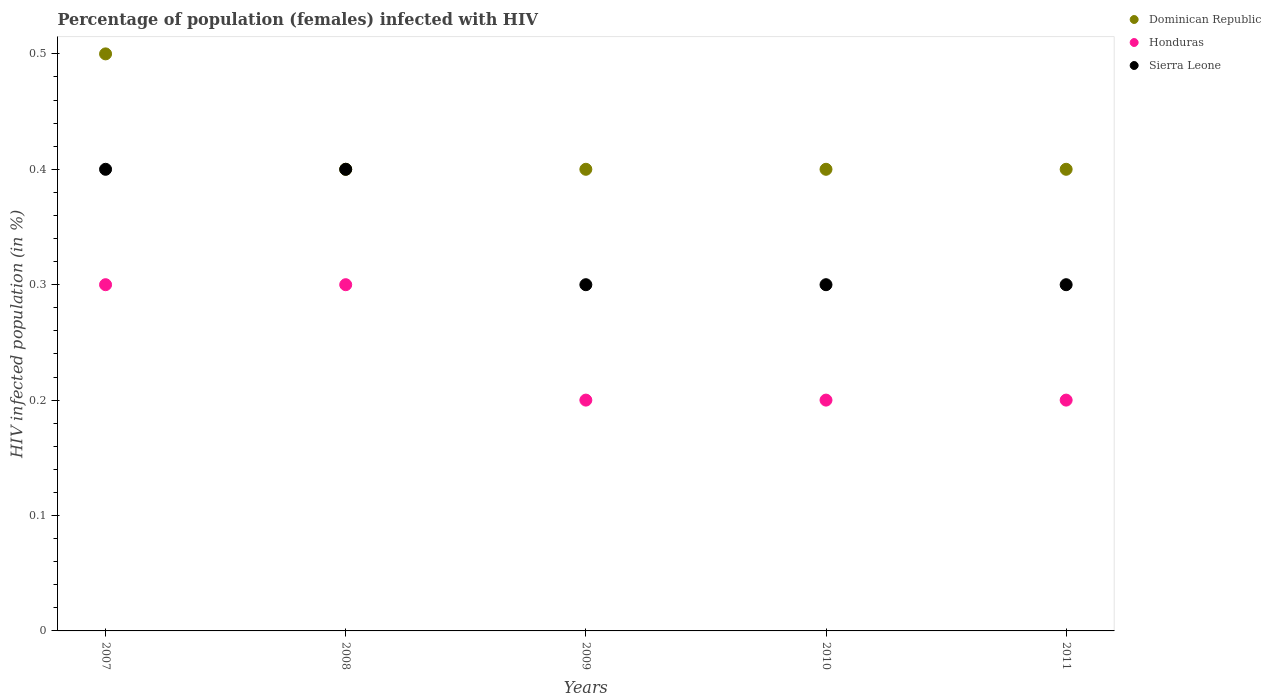Across all years, what is the maximum percentage of HIV infected female population in Sierra Leone?
Provide a succinct answer. 0.4. Across all years, what is the minimum percentage of HIV infected female population in Honduras?
Provide a succinct answer. 0.2. In which year was the percentage of HIV infected female population in Dominican Republic maximum?
Offer a very short reply. 2007. What is the total percentage of HIV infected female population in Honduras in the graph?
Make the answer very short. 1.2. What is the difference between the percentage of HIV infected female population in Honduras in 2008 and that in 2009?
Offer a terse response. 0.1. What is the average percentage of HIV infected female population in Dominican Republic per year?
Your answer should be compact. 0.42. In the year 2008, what is the difference between the percentage of HIV infected female population in Dominican Republic and percentage of HIV infected female population in Sierra Leone?
Offer a very short reply. 0. What is the ratio of the percentage of HIV infected female population in Sierra Leone in 2007 to that in 2009?
Your response must be concise. 1.33. What is the difference between the highest and the lowest percentage of HIV infected female population in Dominican Republic?
Give a very brief answer. 0.1. In how many years, is the percentage of HIV infected female population in Sierra Leone greater than the average percentage of HIV infected female population in Sierra Leone taken over all years?
Offer a very short reply. 2. Does the percentage of HIV infected female population in Honduras monotonically increase over the years?
Offer a terse response. No. Is the percentage of HIV infected female population in Honduras strictly greater than the percentage of HIV infected female population in Sierra Leone over the years?
Provide a succinct answer. No. Is the percentage of HIV infected female population in Sierra Leone strictly less than the percentage of HIV infected female population in Dominican Republic over the years?
Your answer should be very brief. No. How many years are there in the graph?
Offer a terse response. 5. Does the graph contain any zero values?
Offer a very short reply. No. How are the legend labels stacked?
Ensure brevity in your answer.  Vertical. What is the title of the graph?
Make the answer very short. Percentage of population (females) infected with HIV. Does "Slovenia" appear as one of the legend labels in the graph?
Your answer should be very brief. No. What is the label or title of the X-axis?
Provide a short and direct response. Years. What is the label or title of the Y-axis?
Make the answer very short. HIV infected population (in %). What is the HIV infected population (in %) in Dominican Republic in 2007?
Your answer should be compact. 0.5. What is the HIV infected population (in %) in Honduras in 2007?
Your answer should be very brief. 0.3. What is the HIV infected population (in %) in Dominican Republic in 2008?
Keep it short and to the point. 0.4. What is the HIV infected population (in %) in Sierra Leone in 2008?
Your response must be concise. 0.4. What is the HIV infected population (in %) of Dominican Republic in 2009?
Give a very brief answer. 0.4. What is the HIV infected population (in %) of Dominican Republic in 2010?
Your response must be concise. 0.4. What is the HIV infected population (in %) of Sierra Leone in 2010?
Keep it short and to the point. 0.3. What is the HIV infected population (in %) in Dominican Republic in 2011?
Provide a succinct answer. 0.4. Across all years, what is the maximum HIV infected population (in %) of Honduras?
Your answer should be very brief. 0.3. Across all years, what is the maximum HIV infected population (in %) of Sierra Leone?
Offer a very short reply. 0.4. Across all years, what is the minimum HIV infected population (in %) in Honduras?
Your response must be concise. 0.2. Across all years, what is the minimum HIV infected population (in %) in Sierra Leone?
Offer a terse response. 0.3. What is the total HIV infected population (in %) of Dominican Republic in the graph?
Offer a very short reply. 2.1. What is the total HIV infected population (in %) of Honduras in the graph?
Provide a succinct answer. 1.2. What is the total HIV infected population (in %) of Sierra Leone in the graph?
Your answer should be very brief. 1.7. What is the difference between the HIV infected population (in %) of Honduras in 2007 and that in 2008?
Your answer should be compact. 0. What is the difference between the HIV infected population (in %) of Sierra Leone in 2007 and that in 2008?
Offer a very short reply. 0. What is the difference between the HIV infected population (in %) in Honduras in 2007 and that in 2009?
Your response must be concise. 0.1. What is the difference between the HIV infected population (in %) of Sierra Leone in 2007 and that in 2009?
Keep it short and to the point. 0.1. What is the difference between the HIV infected population (in %) of Dominican Republic in 2007 and that in 2010?
Your response must be concise. 0.1. What is the difference between the HIV infected population (in %) of Sierra Leone in 2007 and that in 2010?
Your answer should be compact. 0.1. What is the difference between the HIV infected population (in %) in Dominican Republic in 2007 and that in 2011?
Your answer should be compact. 0.1. What is the difference between the HIV infected population (in %) in Honduras in 2007 and that in 2011?
Keep it short and to the point. 0.1. What is the difference between the HIV infected population (in %) in Sierra Leone in 2007 and that in 2011?
Provide a succinct answer. 0.1. What is the difference between the HIV infected population (in %) in Dominican Republic in 2008 and that in 2009?
Your response must be concise. 0. What is the difference between the HIV infected population (in %) in Sierra Leone in 2008 and that in 2010?
Your answer should be compact. 0.1. What is the difference between the HIV infected population (in %) in Dominican Republic in 2008 and that in 2011?
Your answer should be compact. 0. What is the difference between the HIV infected population (in %) in Honduras in 2008 and that in 2011?
Provide a succinct answer. 0.1. What is the difference between the HIV infected population (in %) of Sierra Leone in 2008 and that in 2011?
Offer a terse response. 0.1. What is the difference between the HIV infected population (in %) of Dominican Republic in 2009 and that in 2010?
Your answer should be very brief. 0. What is the difference between the HIV infected population (in %) of Honduras in 2009 and that in 2010?
Your answer should be very brief. 0. What is the difference between the HIV infected population (in %) in Dominican Republic in 2010 and that in 2011?
Make the answer very short. 0. What is the difference between the HIV infected population (in %) of Sierra Leone in 2010 and that in 2011?
Your answer should be very brief. 0. What is the difference between the HIV infected population (in %) of Dominican Republic in 2007 and the HIV infected population (in %) of Honduras in 2008?
Provide a succinct answer. 0.2. What is the difference between the HIV infected population (in %) in Dominican Republic in 2007 and the HIV infected population (in %) in Sierra Leone in 2008?
Your answer should be very brief. 0.1. What is the difference between the HIV infected population (in %) of Honduras in 2007 and the HIV infected population (in %) of Sierra Leone in 2009?
Provide a short and direct response. 0. What is the difference between the HIV infected population (in %) in Dominican Republic in 2007 and the HIV infected population (in %) in Sierra Leone in 2010?
Give a very brief answer. 0.2. What is the difference between the HIV infected population (in %) of Dominican Republic in 2007 and the HIV infected population (in %) of Honduras in 2011?
Make the answer very short. 0.3. What is the difference between the HIV infected population (in %) of Dominican Republic in 2008 and the HIV infected population (in %) of Sierra Leone in 2009?
Make the answer very short. 0.1. What is the difference between the HIV infected population (in %) in Dominican Republic in 2008 and the HIV infected population (in %) in Honduras in 2010?
Ensure brevity in your answer.  0.2. What is the difference between the HIV infected population (in %) in Honduras in 2008 and the HIV infected population (in %) in Sierra Leone in 2010?
Keep it short and to the point. 0. What is the difference between the HIV infected population (in %) in Dominican Republic in 2008 and the HIV infected population (in %) in Sierra Leone in 2011?
Provide a short and direct response. 0.1. What is the difference between the HIV infected population (in %) in Honduras in 2008 and the HIV infected population (in %) in Sierra Leone in 2011?
Your answer should be compact. 0. What is the difference between the HIV infected population (in %) in Dominican Republic in 2009 and the HIV infected population (in %) in Honduras in 2011?
Give a very brief answer. 0.2. What is the difference between the HIV infected population (in %) of Dominican Republic in 2010 and the HIV infected population (in %) of Honduras in 2011?
Give a very brief answer. 0.2. What is the average HIV infected population (in %) in Dominican Republic per year?
Your answer should be very brief. 0.42. What is the average HIV infected population (in %) in Honduras per year?
Your answer should be compact. 0.24. What is the average HIV infected population (in %) in Sierra Leone per year?
Provide a short and direct response. 0.34. In the year 2007, what is the difference between the HIV infected population (in %) of Dominican Republic and HIV infected population (in %) of Honduras?
Offer a terse response. 0.2. In the year 2007, what is the difference between the HIV infected population (in %) of Dominican Republic and HIV infected population (in %) of Sierra Leone?
Give a very brief answer. 0.1. In the year 2007, what is the difference between the HIV infected population (in %) of Honduras and HIV infected population (in %) of Sierra Leone?
Ensure brevity in your answer.  -0.1. In the year 2008, what is the difference between the HIV infected population (in %) of Dominican Republic and HIV infected population (in %) of Sierra Leone?
Keep it short and to the point. 0. In the year 2009, what is the difference between the HIV infected population (in %) in Dominican Republic and HIV infected population (in %) in Honduras?
Your answer should be very brief. 0.2. In the year 2010, what is the difference between the HIV infected population (in %) of Dominican Republic and HIV infected population (in %) of Honduras?
Your answer should be very brief. 0.2. In the year 2010, what is the difference between the HIV infected population (in %) of Dominican Republic and HIV infected population (in %) of Sierra Leone?
Provide a succinct answer. 0.1. In the year 2010, what is the difference between the HIV infected population (in %) of Honduras and HIV infected population (in %) of Sierra Leone?
Give a very brief answer. -0.1. In the year 2011, what is the difference between the HIV infected population (in %) of Dominican Republic and HIV infected population (in %) of Honduras?
Your answer should be compact. 0.2. What is the ratio of the HIV infected population (in %) of Sierra Leone in 2007 to that in 2008?
Provide a succinct answer. 1. What is the ratio of the HIV infected population (in %) of Dominican Republic in 2007 to that in 2009?
Offer a very short reply. 1.25. What is the ratio of the HIV infected population (in %) of Sierra Leone in 2007 to that in 2009?
Your answer should be compact. 1.33. What is the ratio of the HIV infected population (in %) of Dominican Republic in 2007 to that in 2010?
Offer a terse response. 1.25. What is the ratio of the HIV infected population (in %) of Honduras in 2007 to that in 2010?
Make the answer very short. 1.5. What is the ratio of the HIV infected population (in %) in Dominican Republic in 2007 to that in 2011?
Offer a very short reply. 1.25. What is the ratio of the HIV infected population (in %) in Dominican Republic in 2008 to that in 2009?
Your answer should be very brief. 1. What is the ratio of the HIV infected population (in %) in Honduras in 2008 to that in 2009?
Your response must be concise. 1.5. What is the ratio of the HIV infected population (in %) of Sierra Leone in 2008 to that in 2009?
Your answer should be compact. 1.33. What is the ratio of the HIV infected population (in %) in Honduras in 2009 to that in 2011?
Offer a very short reply. 1. What is the ratio of the HIV infected population (in %) in Sierra Leone in 2009 to that in 2011?
Provide a succinct answer. 1. What is the ratio of the HIV infected population (in %) of Honduras in 2010 to that in 2011?
Make the answer very short. 1. What is the difference between the highest and the second highest HIV infected population (in %) of Dominican Republic?
Provide a short and direct response. 0.1. What is the difference between the highest and the second highest HIV infected population (in %) in Honduras?
Your answer should be compact. 0. What is the difference between the highest and the second highest HIV infected population (in %) of Sierra Leone?
Provide a succinct answer. 0. What is the difference between the highest and the lowest HIV infected population (in %) in Dominican Republic?
Your answer should be compact. 0.1. What is the difference between the highest and the lowest HIV infected population (in %) in Honduras?
Offer a terse response. 0.1. 